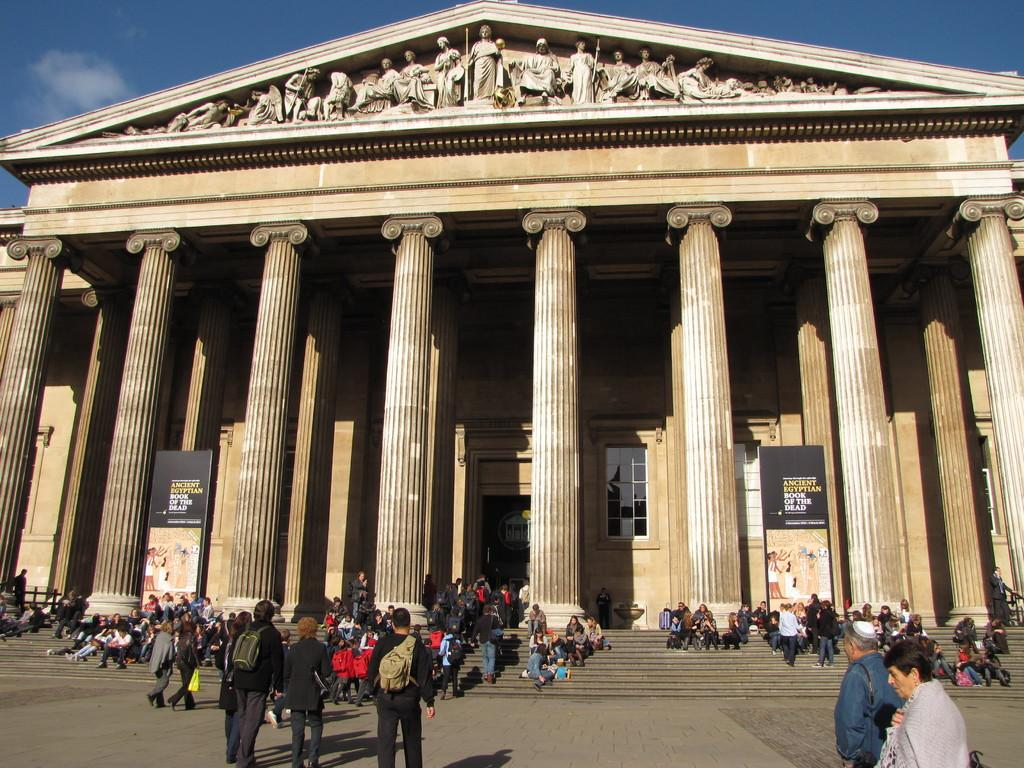<image>
Relay a brief, clear account of the picture shown. People visit a large building with a sign that reads Ancient Egyptian Book of the Dead. 